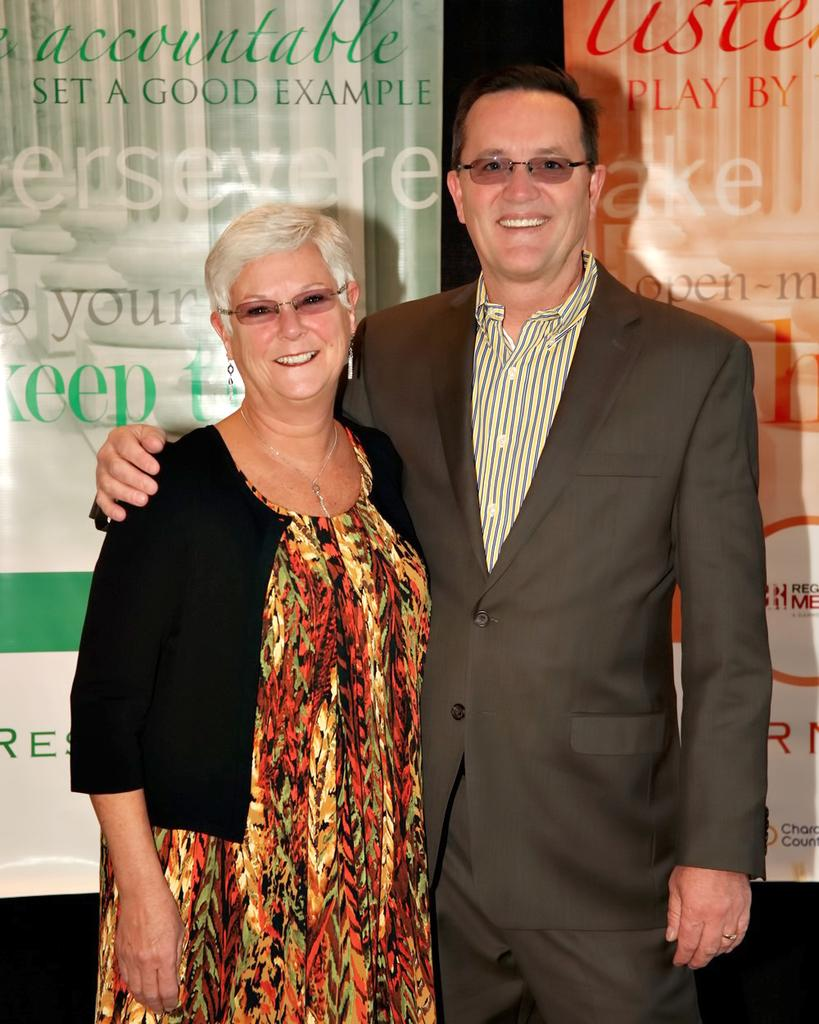How many people are present in the image? There are two people standing in the image. What can be seen on the banners in the image? There are two banners with text in the image. What type of collar can be seen on the tooth in the image? There is no tooth or collar present in the image. What color is the underwear worn by the people in the image? We cannot determine the color of any underwear worn by the people in the image, as they are not visible. 